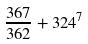<formula> <loc_0><loc_0><loc_500><loc_500>\frac { 3 6 7 } { 3 6 2 } + 3 2 4 ^ { 7 }</formula> 